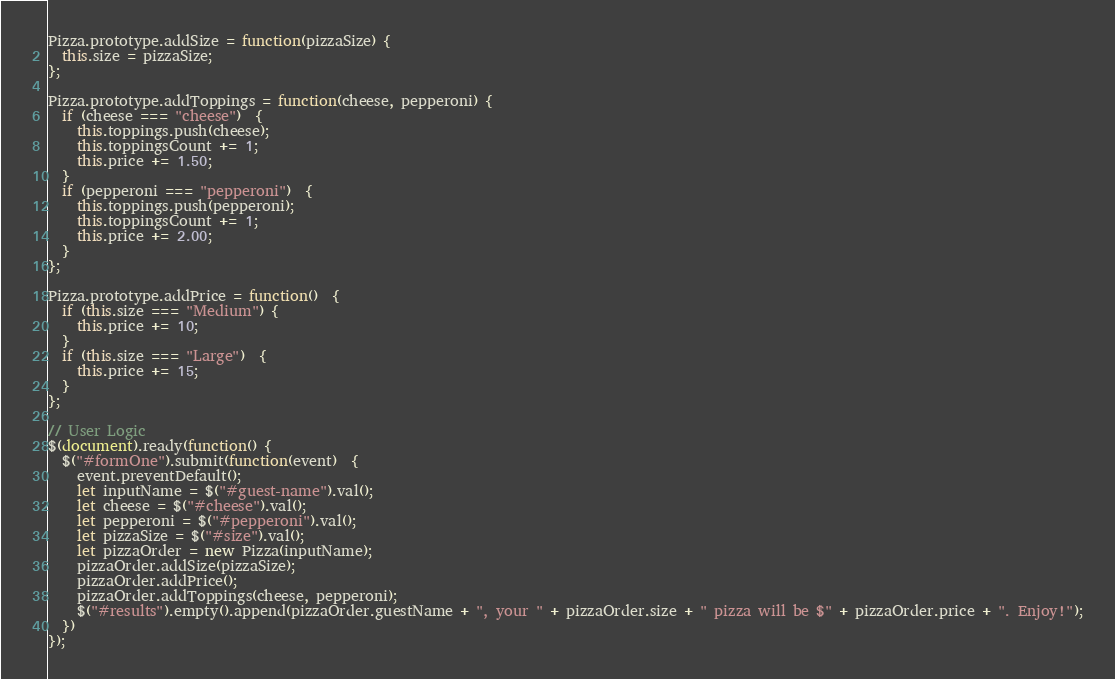<code> <loc_0><loc_0><loc_500><loc_500><_JavaScript_>
Pizza.prototype.addSize = function(pizzaSize) {
  this.size = pizzaSize;
};

Pizza.prototype.addToppings = function(cheese, pepperoni) {
  if (cheese === "cheese")  {
    this.toppings.push(cheese);
    this.toppingsCount += 1;
    this.price += 1.50;
  }
  if (pepperoni === "pepperoni")  {
    this.toppings.push(pepperoni);
    this.toppingsCount += 1;
    this.price += 2.00;
  }
};

Pizza.prototype.addPrice = function()  {
  if (this.size === "Medium") {
    this.price += 10;
  }
  if (this.size === "Large")  {
    this.price += 15;
  }
};

// User Logic
$(document).ready(function() {
  $("#formOne").submit(function(event)  {
    event.preventDefault();
    let inputName = $("#guest-name").val();
    let cheese = $("#cheese").val();
    let pepperoni = $("#pepperoni").val();
    let pizzaSize = $("#size").val();
    let pizzaOrder = new Pizza(inputName);
    pizzaOrder.addSize(pizzaSize);
    pizzaOrder.addPrice();
    pizzaOrder.addToppings(cheese, pepperoni);
    $("#results").empty().append(pizzaOrder.guestName + ", your " + pizzaOrder.size + " pizza will be $" + pizzaOrder.price + ". Enjoy!");
  })
});</code> 